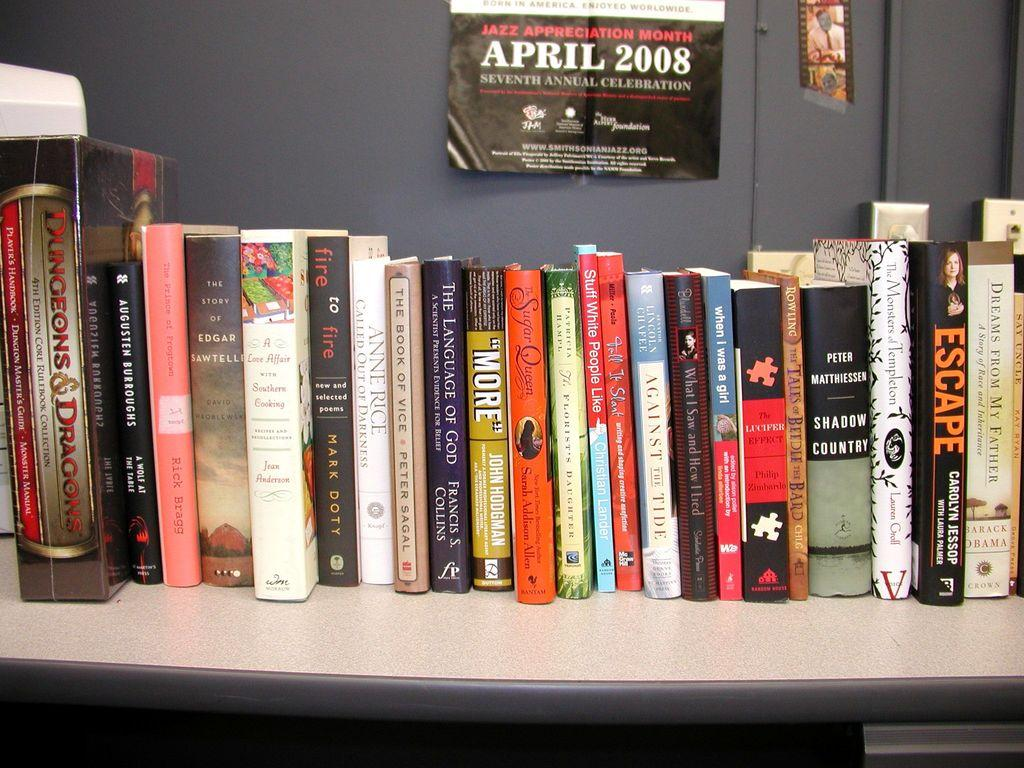<image>
Relay a brief, clear account of the picture shown. A poster advertising Jazz Appreciation month is hanging above a book shelf, with books like Language of God and Stuff White People Like. 